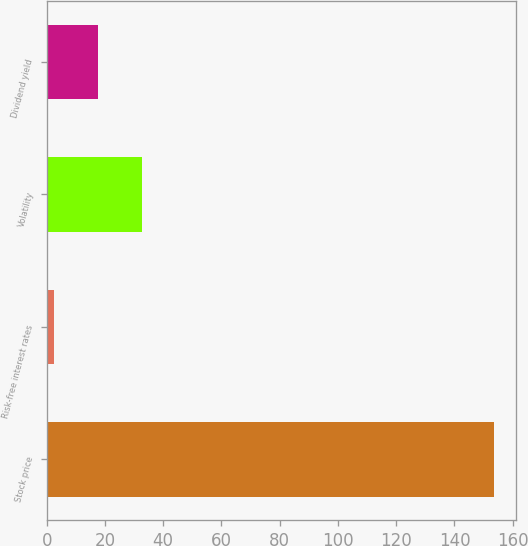<chart> <loc_0><loc_0><loc_500><loc_500><bar_chart><fcel>Stock price<fcel>Risk-free interest rates<fcel>Volatility<fcel>Dividend yield<nl><fcel>153.54<fcel>2.68<fcel>32.86<fcel>17.77<nl></chart> 